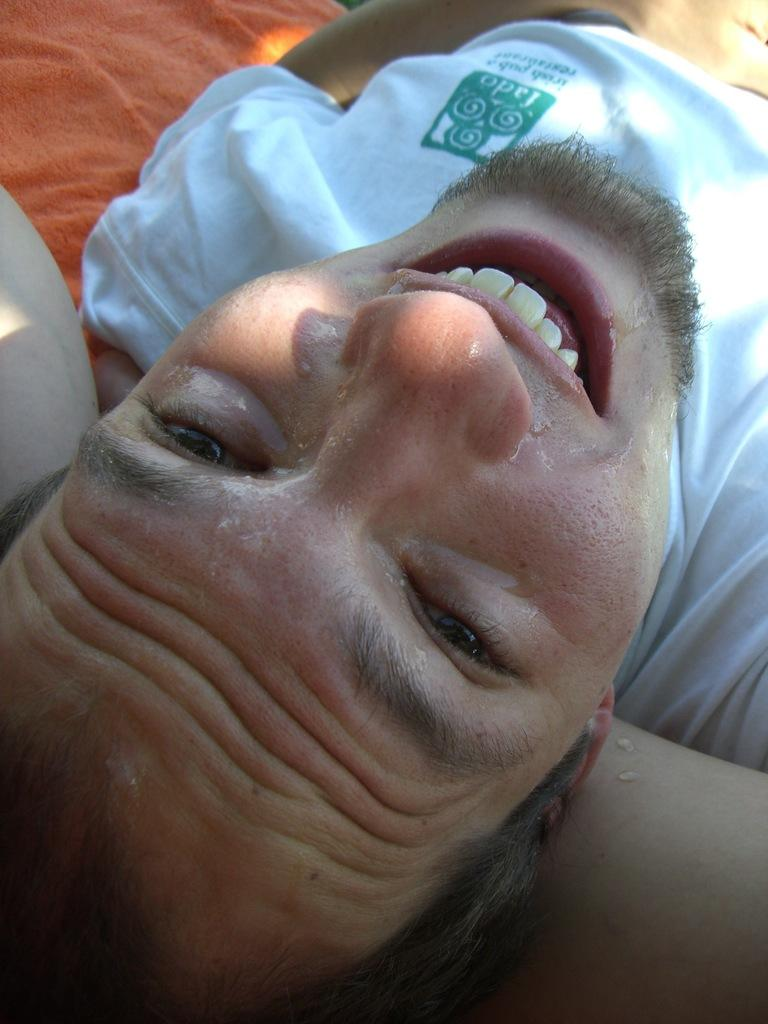What is the main subject of the image? There is a person in the image. What is the person doing in the image? The person is lying down. What expression does the person have in the image? The person is smiling. How many hands are visible in the image? There are no hands visible in the image; it only shows a person lying down and smiling. 